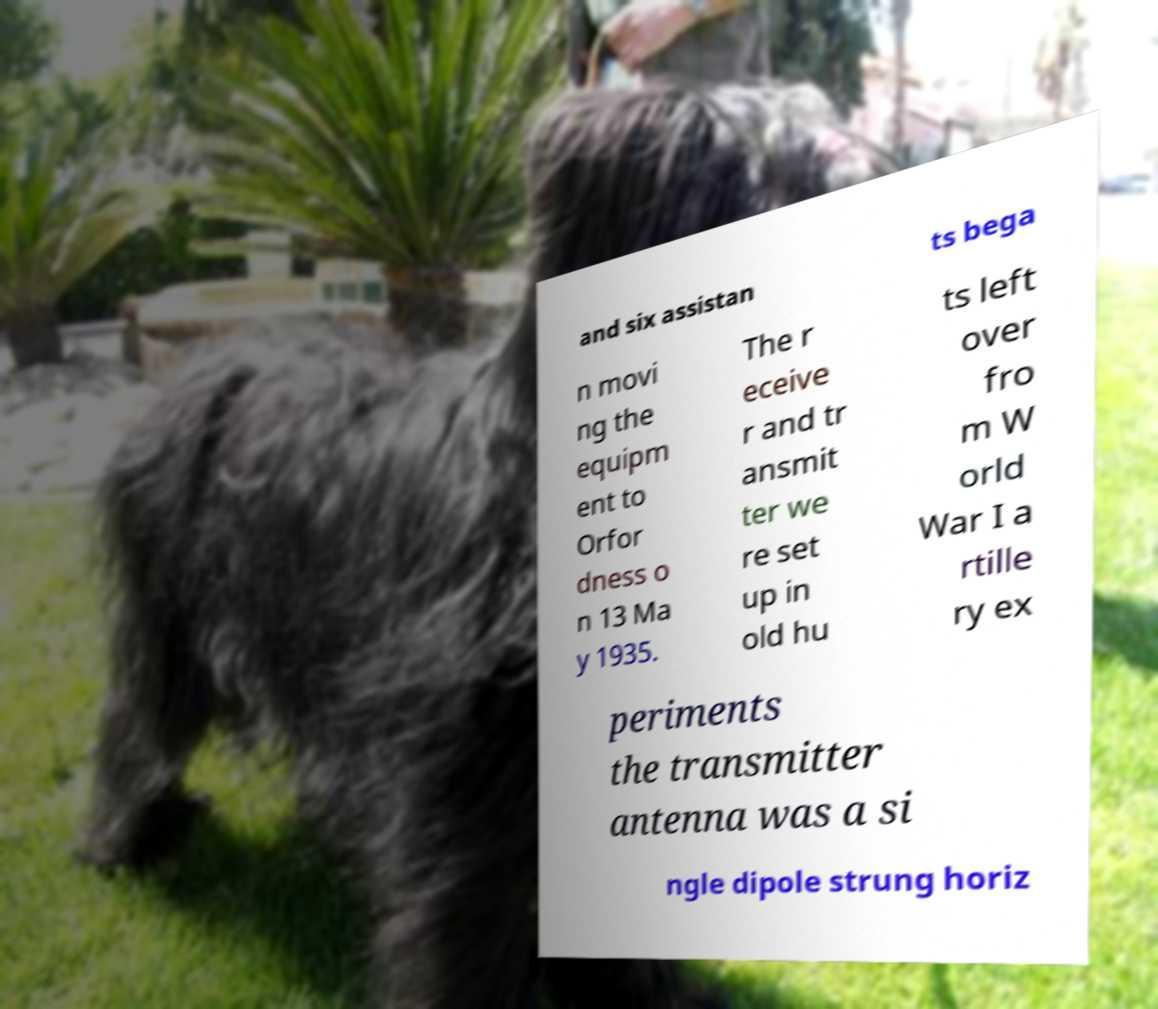What messages or text are displayed in this image? I need them in a readable, typed format. and six assistan ts bega n movi ng the equipm ent to Orfor dness o n 13 Ma y 1935. The r eceive r and tr ansmit ter we re set up in old hu ts left over fro m W orld War I a rtille ry ex periments the transmitter antenna was a si ngle dipole strung horiz 